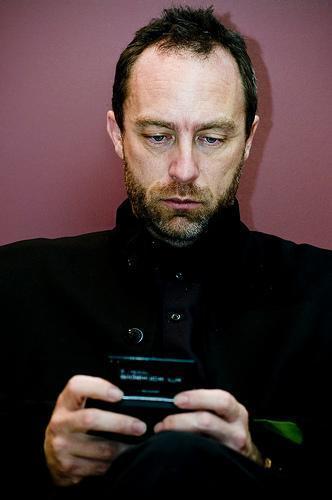How many people are in the picture?
Give a very brief answer. 1. 